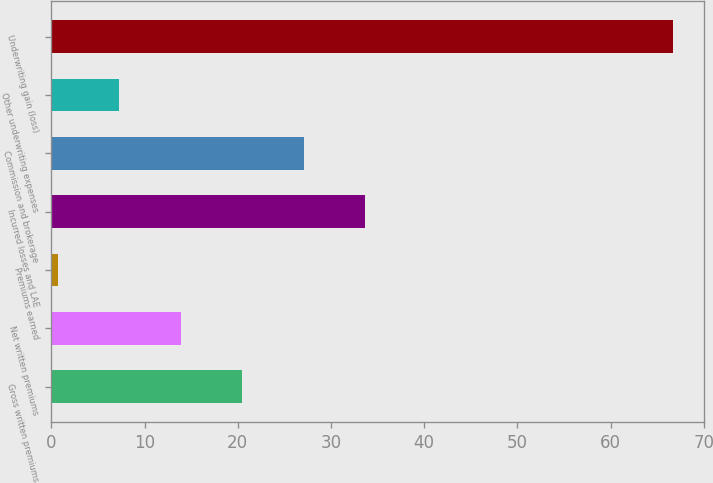<chart> <loc_0><loc_0><loc_500><loc_500><bar_chart><fcel>Gross written premiums<fcel>Net written premiums<fcel>Premiums earned<fcel>Incurred losses and LAE<fcel>Commission and brokerage<fcel>Other underwriting expenses<fcel>Underwriting gain (loss)<nl><fcel>20.5<fcel>13.9<fcel>0.7<fcel>33.7<fcel>27.1<fcel>7.3<fcel>66.7<nl></chart> 